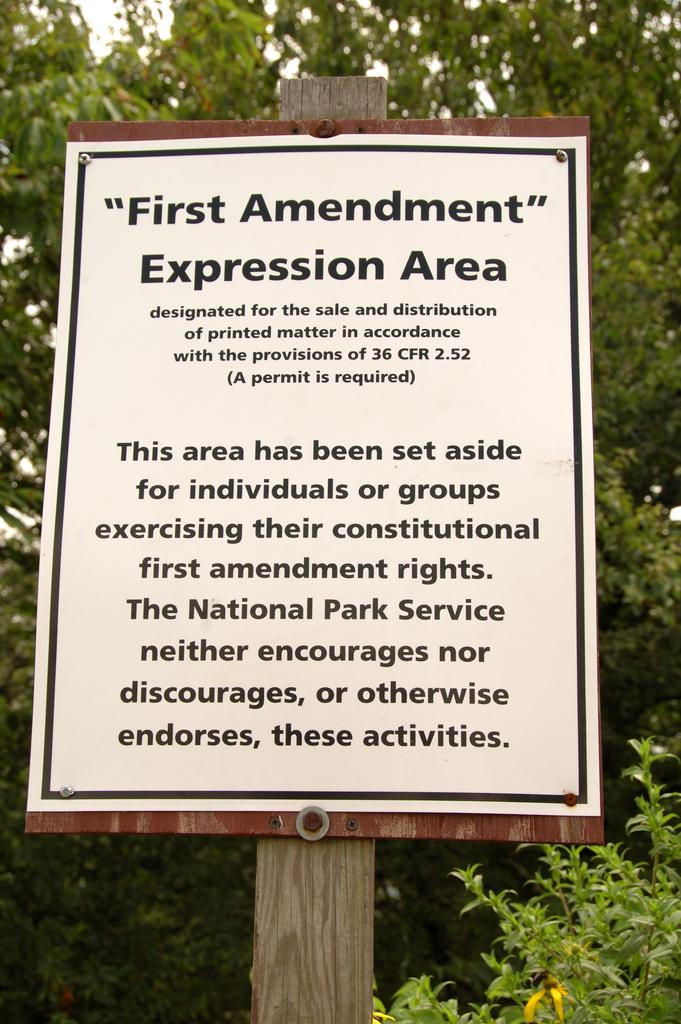What objects are in the foreground of the picture? There is a board, a pole, and a tree in the foreground of the picture. What is written on the board? There is text on the board. What can be seen in the background of the picture? There are trees in the background of the picture. What type of science experiment is being conducted with the boats in the image? There are no boats present in the image, so it is not possible to determine if a science experiment is being conducted. 